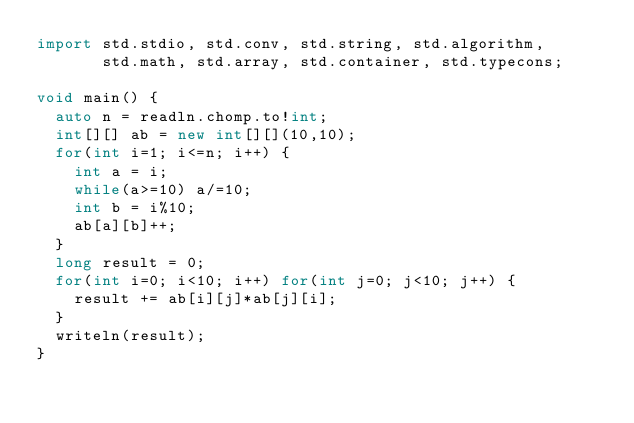<code> <loc_0><loc_0><loc_500><loc_500><_D_>import std.stdio, std.conv, std.string, std.algorithm,
       std.math, std.array, std.container, std.typecons;

void main() {
  auto n = readln.chomp.to!int;
  int[][] ab = new int[][](10,10);
  for(int i=1; i<=n; i++) {
    int a = i;
    while(a>=10) a/=10;
    int b = i%10;
    ab[a][b]++;
  }
  long result = 0;
  for(int i=0; i<10; i++) for(int j=0; j<10; j++) {
    result += ab[i][j]*ab[j][i];
  }
  writeln(result);
}
</code> 